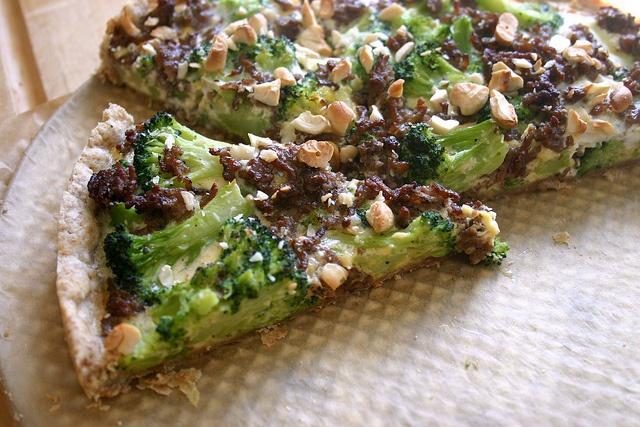Describe the objects in this image and their specific colors. I can see pizza in tan, olive, black, and maroon tones, pizza in tan, olive, maroon, and white tones, broccoli in tan, olive, black, and darkgreen tones, broccoli in tan, black, darkgreen, and olive tones, and broccoli in tan, black, olive, ivory, and maroon tones in this image. 